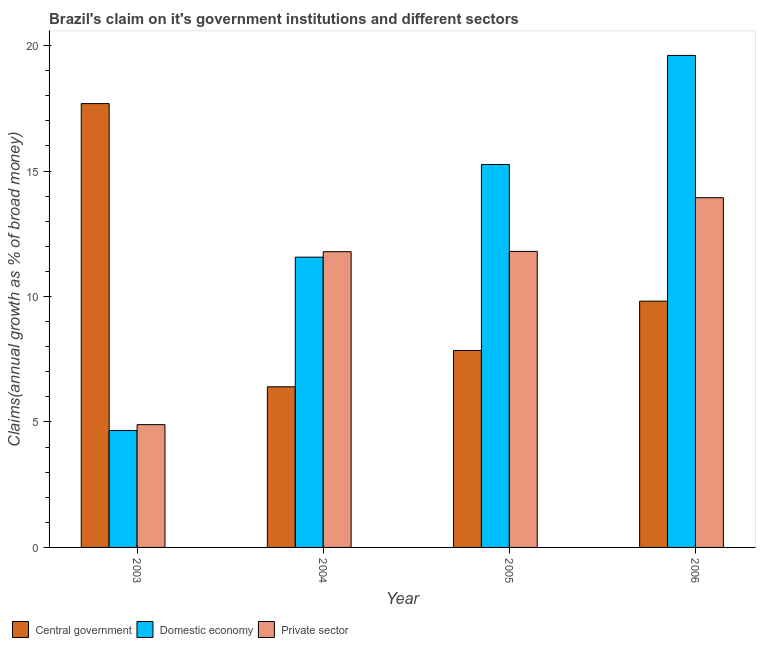How many bars are there on the 4th tick from the left?
Give a very brief answer. 3. What is the label of the 3rd group of bars from the left?
Your answer should be very brief. 2005. What is the percentage of claim on the private sector in 2006?
Give a very brief answer. 13.94. Across all years, what is the maximum percentage of claim on the central government?
Your answer should be very brief. 17.69. Across all years, what is the minimum percentage of claim on the domestic economy?
Your response must be concise. 4.66. In which year was the percentage of claim on the domestic economy maximum?
Provide a succinct answer. 2006. What is the total percentage of claim on the central government in the graph?
Your answer should be very brief. 41.76. What is the difference between the percentage of claim on the central government in 2003 and that in 2006?
Provide a succinct answer. 7.87. What is the difference between the percentage of claim on the private sector in 2003 and the percentage of claim on the central government in 2006?
Provide a succinct answer. -9.04. What is the average percentage of claim on the domestic economy per year?
Provide a short and direct response. 12.77. In the year 2006, what is the difference between the percentage of claim on the private sector and percentage of claim on the domestic economy?
Your answer should be compact. 0. In how many years, is the percentage of claim on the central government greater than 2 %?
Provide a short and direct response. 4. What is the ratio of the percentage of claim on the central government in 2004 to that in 2005?
Your response must be concise. 0.82. What is the difference between the highest and the second highest percentage of claim on the domestic economy?
Your answer should be compact. 4.35. What is the difference between the highest and the lowest percentage of claim on the central government?
Your answer should be compact. 11.29. Is the sum of the percentage of claim on the private sector in 2003 and 2005 greater than the maximum percentage of claim on the central government across all years?
Offer a terse response. Yes. What does the 3rd bar from the left in 2005 represents?
Provide a short and direct response. Private sector. What does the 3rd bar from the right in 2003 represents?
Provide a succinct answer. Central government. Is it the case that in every year, the sum of the percentage of claim on the central government and percentage of claim on the domestic economy is greater than the percentage of claim on the private sector?
Make the answer very short. Yes. How many bars are there?
Offer a terse response. 12. How many years are there in the graph?
Your answer should be compact. 4. What is the difference between two consecutive major ticks on the Y-axis?
Provide a succinct answer. 5. Does the graph contain any zero values?
Make the answer very short. No. Does the graph contain grids?
Keep it short and to the point. No. How many legend labels are there?
Your answer should be very brief. 3. What is the title of the graph?
Keep it short and to the point. Brazil's claim on it's government institutions and different sectors. Does "Other sectors" appear as one of the legend labels in the graph?
Provide a short and direct response. No. What is the label or title of the X-axis?
Your answer should be compact. Year. What is the label or title of the Y-axis?
Your answer should be very brief. Claims(annual growth as % of broad money). What is the Claims(annual growth as % of broad money) of Central government in 2003?
Your answer should be compact. 17.69. What is the Claims(annual growth as % of broad money) in Domestic economy in 2003?
Ensure brevity in your answer.  4.66. What is the Claims(annual growth as % of broad money) of Private sector in 2003?
Provide a succinct answer. 4.89. What is the Claims(annual growth as % of broad money) in Central government in 2004?
Offer a very short reply. 6.4. What is the Claims(annual growth as % of broad money) in Domestic economy in 2004?
Ensure brevity in your answer.  11.57. What is the Claims(annual growth as % of broad money) of Private sector in 2004?
Your answer should be very brief. 11.79. What is the Claims(annual growth as % of broad money) of Central government in 2005?
Provide a succinct answer. 7.85. What is the Claims(annual growth as % of broad money) of Domestic economy in 2005?
Keep it short and to the point. 15.26. What is the Claims(annual growth as % of broad money) in Private sector in 2005?
Provide a succinct answer. 11.8. What is the Claims(annual growth as % of broad money) in Central government in 2006?
Keep it short and to the point. 9.82. What is the Claims(annual growth as % of broad money) in Domestic economy in 2006?
Give a very brief answer. 19.61. What is the Claims(annual growth as % of broad money) of Private sector in 2006?
Provide a succinct answer. 13.94. Across all years, what is the maximum Claims(annual growth as % of broad money) in Central government?
Your response must be concise. 17.69. Across all years, what is the maximum Claims(annual growth as % of broad money) of Domestic economy?
Your answer should be compact. 19.61. Across all years, what is the maximum Claims(annual growth as % of broad money) in Private sector?
Provide a succinct answer. 13.94. Across all years, what is the minimum Claims(annual growth as % of broad money) in Central government?
Offer a terse response. 6.4. Across all years, what is the minimum Claims(annual growth as % of broad money) in Domestic economy?
Keep it short and to the point. 4.66. Across all years, what is the minimum Claims(annual growth as % of broad money) in Private sector?
Offer a terse response. 4.89. What is the total Claims(annual growth as % of broad money) in Central government in the graph?
Provide a short and direct response. 41.76. What is the total Claims(annual growth as % of broad money) in Domestic economy in the graph?
Offer a very short reply. 51.1. What is the total Claims(annual growth as % of broad money) of Private sector in the graph?
Your answer should be compact. 42.42. What is the difference between the Claims(annual growth as % of broad money) in Central government in 2003 and that in 2004?
Your answer should be compact. 11.29. What is the difference between the Claims(annual growth as % of broad money) of Domestic economy in 2003 and that in 2004?
Offer a very short reply. -6.91. What is the difference between the Claims(annual growth as % of broad money) of Private sector in 2003 and that in 2004?
Offer a terse response. -6.89. What is the difference between the Claims(annual growth as % of broad money) in Central government in 2003 and that in 2005?
Ensure brevity in your answer.  9.84. What is the difference between the Claims(annual growth as % of broad money) of Domestic economy in 2003 and that in 2005?
Ensure brevity in your answer.  -10.6. What is the difference between the Claims(annual growth as % of broad money) of Private sector in 2003 and that in 2005?
Your response must be concise. -6.9. What is the difference between the Claims(annual growth as % of broad money) of Central government in 2003 and that in 2006?
Give a very brief answer. 7.87. What is the difference between the Claims(annual growth as % of broad money) of Domestic economy in 2003 and that in 2006?
Make the answer very short. -14.95. What is the difference between the Claims(annual growth as % of broad money) in Private sector in 2003 and that in 2006?
Keep it short and to the point. -9.04. What is the difference between the Claims(annual growth as % of broad money) in Central government in 2004 and that in 2005?
Give a very brief answer. -1.45. What is the difference between the Claims(annual growth as % of broad money) in Domestic economy in 2004 and that in 2005?
Ensure brevity in your answer.  -3.69. What is the difference between the Claims(annual growth as % of broad money) of Private sector in 2004 and that in 2005?
Keep it short and to the point. -0.01. What is the difference between the Claims(annual growth as % of broad money) in Central government in 2004 and that in 2006?
Your answer should be compact. -3.41. What is the difference between the Claims(annual growth as % of broad money) in Domestic economy in 2004 and that in 2006?
Offer a very short reply. -8.04. What is the difference between the Claims(annual growth as % of broad money) in Private sector in 2004 and that in 2006?
Offer a very short reply. -2.15. What is the difference between the Claims(annual growth as % of broad money) in Central government in 2005 and that in 2006?
Your response must be concise. -1.97. What is the difference between the Claims(annual growth as % of broad money) in Domestic economy in 2005 and that in 2006?
Provide a succinct answer. -4.35. What is the difference between the Claims(annual growth as % of broad money) of Private sector in 2005 and that in 2006?
Make the answer very short. -2.14. What is the difference between the Claims(annual growth as % of broad money) in Central government in 2003 and the Claims(annual growth as % of broad money) in Domestic economy in 2004?
Provide a succinct answer. 6.12. What is the difference between the Claims(annual growth as % of broad money) of Central government in 2003 and the Claims(annual growth as % of broad money) of Private sector in 2004?
Ensure brevity in your answer.  5.9. What is the difference between the Claims(annual growth as % of broad money) in Domestic economy in 2003 and the Claims(annual growth as % of broad money) in Private sector in 2004?
Ensure brevity in your answer.  -7.13. What is the difference between the Claims(annual growth as % of broad money) in Central government in 2003 and the Claims(annual growth as % of broad money) in Domestic economy in 2005?
Make the answer very short. 2.43. What is the difference between the Claims(annual growth as % of broad money) in Central government in 2003 and the Claims(annual growth as % of broad money) in Private sector in 2005?
Offer a very short reply. 5.89. What is the difference between the Claims(annual growth as % of broad money) in Domestic economy in 2003 and the Claims(annual growth as % of broad money) in Private sector in 2005?
Your answer should be compact. -7.14. What is the difference between the Claims(annual growth as % of broad money) in Central government in 2003 and the Claims(annual growth as % of broad money) in Domestic economy in 2006?
Your answer should be very brief. -1.92. What is the difference between the Claims(annual growth as % of broad money) of Central government in 2003 and the Claims(annual growth as % of broad money) of Private sector in 2006?
Make the answer very short. 3.75. What is the difference between the Claims(annual growth as % of broad money) in Domestic economy in 2003 and the Claims(annual growth as % of broad money) in Private sector in 2006?
Your answer should be compact. -9.28. What is the difference between the Claims(annual growth as % of broad money) of Central government in 2004 and the Claims(annual growth as % of broad money) of Domestic economy in 2005?
Provide a short and direct response. -8.86. What is the difference between the Claims(annual growth as % of broad money) in Central government in 2004 and the Claims(annual growth as % of broad money) in Private sector in 2005?
Your answer should be compact. -5.4. What is the difference between the Claims(annual growth as % of broad money) of Domestic economy in 2004 and the Claims(annual growth as % of broad money) of Private sector in 2005?
Ensure brevity in your answer.  -0.23. What is the difference between the Claims(annual growth as % of broad money) in Central government in 2004 and the Claims(annual growth as % of broad money) in Domestic economy in 2006?
Offer a terse response. -13.21. What is the difference between the Claims(annual growth as % of broad money) of Central government in 2004 and the Claims(annual growth as % of broad money) of Private sector in 2006?
Offer a very short reply. -7.54. What is the difference between the Claims(annual growth as % of broad money) of Domestic economy in 2004 and the Claims(annual growth as % of broad money) of Private sector in 2006?
Make the answer very short. -2.37. What is the difference between the Claims(annual growth as % of broad money) in Central government in 2005 and the Claims(annual growth as % of broad money) in Domestic economy in 2006?
Your response must be concise. -11.76. What is the difference between the Claims(annual growth as % of broad money) of Central government in 2005 and the Claims(annual growth as % of broad money) of Private sector in 2006?
Offer a terse response. -6.09. What is the difference between the Claims(annual growth as % of broad money) of Domestic economy in 2005 and the Claims(annual growth as % of broad money) of Private sector in 2006?
Provide a succinct answer. 1.32. What is the average Claims(annual growth as % of broad money) of Central government per year?
Provide a succinct answer. 10.44. What is the average Claims(annual growth as % of broad money) in Domestic economy per year?
Ensure brevity in your answer.  12.77. What is the average Claims(annual growth as % of broad money) of Private sector per year?
Your response must be concise. 10.6. In the year 2003, what is the difference between the Claims(annual growth as % of broad money) of Central government and Claims(annual growth as % of broad money) of Domestic economy?
Your response must be concise. 13.03. In the year 2003, what is the difference between the Claims(annual growth as % of broad money) in Central government and Claims(annual growth as % of broad money) in Private sector?
Offer a terse response. 12.79. In the year 2003, what is the difference between the Claims(annual growth as % of broad money) in Domestic economy and Claims(annual growth as % of broad money) in Private sector?
Make the answer very short. -0.24. In the year 2004, what is the difference between the Claims(annual growth as % of broad money) of Central government and Claims(annual growth as % of broad money) of Domestic economy?
Make the answer very short. -5.17. In the year 2004, what is the difference between the Claims(annual growth as % of broad money) in Central government and Claims(annual growth as % of broad money) in Private sector?
Make the answer very short. -5.38. In the year 2004, what is the difference between the Claims(annual growth as % of broad money) of Domestic economy and Claims(annual growth as % of broad money) of Private sector?
Your answer should be compact. -0.22. In the year 2005, what is the difference between the Claims(annual growth as % of broad money) of Central government and Claims(annual growth as % of broad money) of Domestic economy?
Make the answer very short. -7.41. In the year 2005, what is the difference between the Claims(annual growth as % of broad money) in Central government and Claims(annual growth as % of broad money) in Private sector?
Offer a very short reply. -3.95. In the year 2005, what is the difference between the Claims(annual growth as % of broad money) in Domestic economy and Claims(annual growth as % of broad money) in Private sector?
Offer a very short reply. 3.46. In the year 2006, what is the difference between the Claims(annual growth as % of broad money) in Central government and Claims(annual growth as % of broad money) in Domestic economy?
Provide a short and direct response. -9.79. In the year 2006, what is the difference between the Claims(annual growth as % of broad money) of Central government and Claims(annual growth as % of broad money) of Private sector?
Your answer should be compact. -4.12. In the year 2006, what is the difference between the Claims(annual growth as % of broad money) in Domestic economy and Claims(annual growth as % of broad money) in Private sector?
Provide a short and direct response. 5.67. What is the ratio of the Claims(annual growth as % of broad money) of Central government in 2003 to that in 2004?
Offer a very short reply. 2.76. What is the ratio of the Claims(annual growth as % of broad money) in Domestic economy in 2003 to that in 2004?
Make the answer very short. 0.4. What is the ratio of the Claims(annual growth as % of broad money) in Private sector in 2003 to that in 2004?
Make the answer very short. 0.42. What is the ratio of the Claims(annual growth as % of broad money) in Central government in 2003 to that in 2005?
Ensure brevity in your answer.  2.25. What is the ratio of the Claims(annual growth as % of broad money) in Domestic economy in 2003 to that in 2005?
Your response must be concise. 0.31. What is the ratio of the Claims(annual growth as % of broad money) of Private sector in 2003 to that in 2005?
Your response must be concise. 0.41. What is the ratio of the Claims(annual growth as % of broad money) of Central government in 2003 to that in 2006?
Your response must be concise. 1.8. What is the ratio of the Claims(annual growth as % of broad money) in Domestic economy in 2003 to that in 2006?
Give a very brief answer. 0.24. What is the ratio of the Claims(annual growth as % of broad money) of Private sector in 2003 to that in 2006?
Your response must be concise. 0.35. What is the ratio of the Claims(annual growth as % of broad money) in Central government in 2004 to that in 2005?
Keep it short and to the point. 0.82. What is the ratio of the Claims(annual growth as % of broad money) in Domestic economy in 2004 to that in 2005?
Give a very brief answer. 0.76. What is the ratio of the Claims(annual growth as % of broad money) in Private sector in 2004 to that in 2005?
Your answer should be very brief. 1. What is the ratio of the Claims(annual growth as % of broad money) in Central government in 2004 to that in 2006?
Your response must be concise. 0.65. What is the ratio of the Claims(annual growth as % of broad money) of Domestic economy in 2004 to that in 2006?
Provide a short and direct response. 0.59. What is the ratio of the Claims(annual growth as % of broad money) in Private sector in 2004 to that in 2006?
Your answer should be very brief. 0.85. What is the ratio of the Claims(annual growth as % of broad money) in Central government in 2005 to that in 2006?
Ensure brevity in your answer.  0.8. What is the ratio of the Claims(annual growth as % of broad money) of Domestic economy in 2005 to that in 2006?
Your answer should be very brief. 0.78. What is the ratio of the Claims(annual growth as % of broad money) of Private sector in 2005 to that in 2006?
Provide a short and direct response. 0.85. What is the difference between the highest and the second highest Claims(annual growth as % of broad money) in Central government?
Give a very brief answer. 7.87. What is the difference between the highest and the second highest Claims(annual growth as % of broad money) of Domestic economy?
Give a very brief answer. 4.35. What is the difference between the highest and the second highest Claims(annual growth as % of broad money) of Private sector?
Give a very brief answer. 2.14. What is the difference between the highest and the lowest Claims(annual growth as % of broad money) of Central government?
Provide a succinct answer. 11.29. What is the difference between the highest and the lowest Claims(annual growth as % of broad money) of Domestic economy?
Offer a very short reply. 14.95. What is the difference between the highest and the lowest Claims(annual growth as % of broad money) in Private sector?
Give a very brief answer. 9.04. 